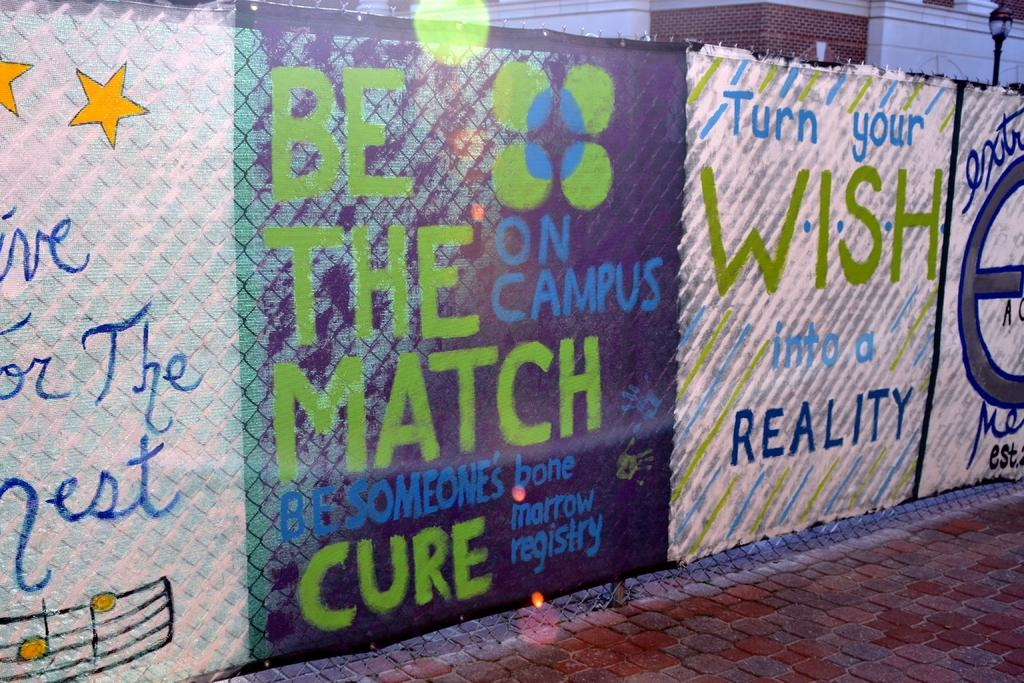Provide a one-sentence caption for the provided image. A sign that says Turn Your Wish Into a Reality. 